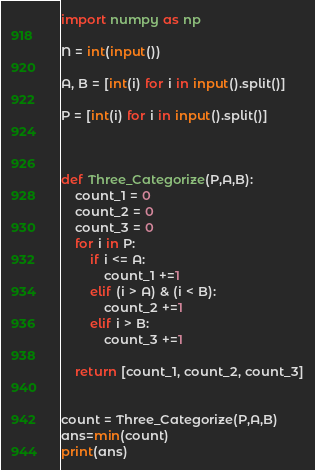Convert code to text. <code><loc_0><loc_0><loc_500><loc_500><_Python_>import numpy as np

N = int(input())

A, B = [int(i) for i in input().split()]

P = [int(i) for i in input().split()]



def Three_Categorize(P,A,B):
    count_1 = 0
    count_2 = 0
    count_3 = 0
    for i in P:
        if i <= A:
            count_1 +=1
        elif (i > A) & (i < B):
            count_2 +=1
        elif i > B:
            count_3 +=1
    
    return [count_1, count_2, count_3]
            
    
count = Three_Categorize(P,A,B)
ans=min(count)
print(ans)
</code> 